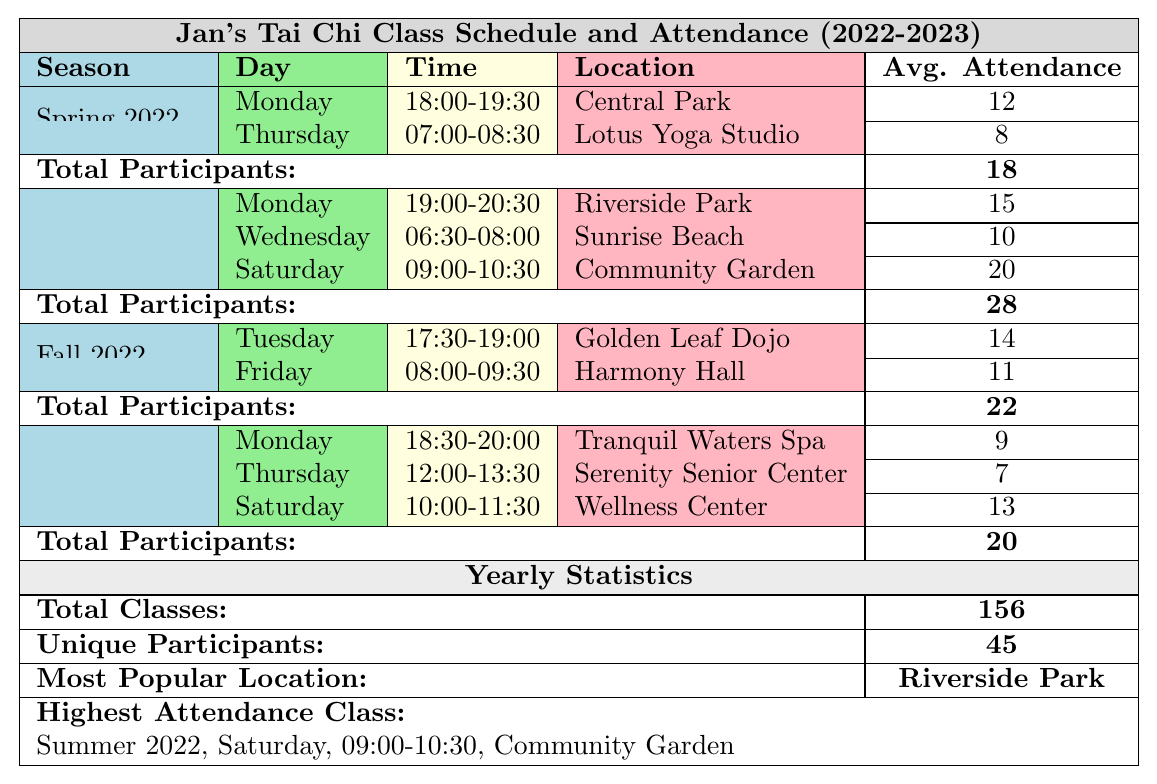What seasons did Jan hold classes in 2022? The table lists four seasons with classes: Spring 2022, Summer 2022, Fall 2022, and Winter 2023.
Answer: Spring 2022, Summer 2022, Fall 2022, Winter 2023 Which class had the highest average attendance? The highest average attendance is 20, which occurred during the Summer 2022 class on Saturday at the Community Garden.
Answer: Community Garden, Summer 2022 How many total classes did Jan offer throughout the year? The table states that there were a total of 156 classes offered over the year.
Answer: 156 What was the average attendance for classes in Fall 2022? In Fall 2022, the average attendance was calculated as (14 + 11) / 2, which totals to 25 for 2 classes, resulting in an average of 12.5.
Answer: 12.5 Did Jan have classes on Sunday? A scan of the table shows that there are no classes listed for Sunday in any of the seasons.
Answer: No How many unique participants attended Jan's classes? The statistics at the bottom of the table indicate that there were a total of 45 unique participants throughout the year.
Answer: 45 What was the average attendance across all classes in Spring 2022? In Spring 2022, average attendance is calculated as (12 + 8) / 2 = 10, since there are two classes.
Answer: 10 Which location hosted the most classes? By examining the table, "Riverside Park" is identified in the Summer 2022 classes, indicating it hosted multiple sessions.
Answer: Riverside Park What was the total average attendance for Winter 2023? The total average attendance for Winter 2023 classes is (9 + 7 + 13) / 3, which results in 9.67, since there are three classes.
Answer: 9.67 In which season did Jan see the highest total number of participants? By analyzing the total participants for each season, Summer 2022 had the highest with 28 participants compared to others.
Answer: Summer 2022 